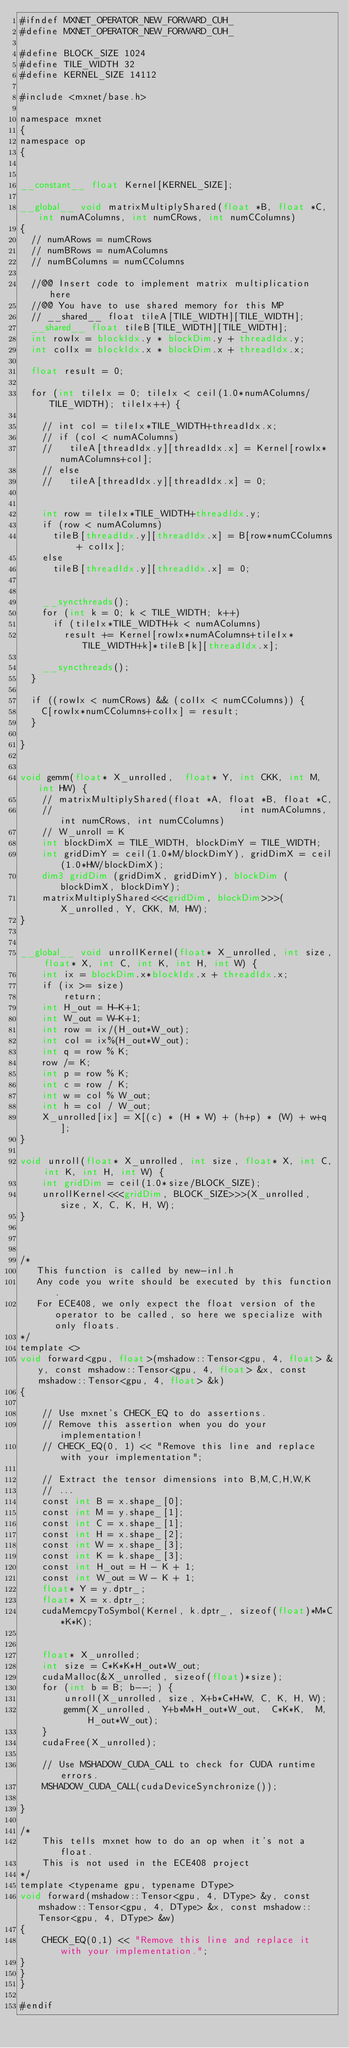Convert code to text. <code><loc_0><loc_0><loc_500><loc_500><_Cuda_>#ifndef MXNET_OPERATOR_NEW_FORWARD_CUH_
#define MXNET_OPERATOR_NEW_FORWARD_CUH_

#define BLOCK_SIZE 1024
#define TILE_WIDTH 32
#define KERNEL_SIZE 14112

#include <mxnet/base.h>

namespace mxnet
{
namespace op
{


__constant__ float Kernel[KERNEL_SIZE];

__global__ void matrixMultiplyShared(float *B, float *C, int numAColumns, int numCRows, int numCColumns) 
{
  // numARows = numCRows
  // numBRows = numAColumns
  // numBColumns = numCColumns

  //@@ Insert code to implement matrix multiplication here
  //@@ You have to use shared memory for this MP
  // __shared__ float tileA[TILE_WIDTH][TILE_WIDTH];
  __shared__ float tileB[TILE_WIDTH][TILE_WIDTH];
  int rowIx = blockIdx.y * blockDim.y + threadIdx.y;
  int colIx = blockIdx.x * blockDim.x + threadIdx.x;

  float result = 0;
  
  for (int tileIx = 0; tileIx < ceil(1.0*numAColumns/TILE_WIDTH); tileIx++) {

    // int col = tileIx*TILE_WIDTH+threadIdx.x;
    // if (col < numAColumns)
    //   tileA[threadIdx.y][threadIdx.x] = Kernel[rowIx*numAColumns+col];
    // else
    //   tileA[threadIdx.y][threadIdx.x] = 0;


    int row = tileIx*TILE_WIDTH+threadIdx.y;
    if (row < numAColumns)
      tileB[threadIdx.y][threadIdx.x] = B[row*numCColumns + colIx];
    else 
      tileB[threadIdx.y][threadIdx.x] = 0;


    __syncthreads();
    for (int k = 0; k < TILE_WIDTH; k++)
      if (tileIx*TILE_WIDTH+k < numAColumns)
        result += Kernel[rowIx*numAColumns+tileIx*TILE_WIDTH+k]*tileB[k][threadIdx.x];
      
    __syncthreads();   
  }
  
  if ((rowIx < numCRows) && (colIx < numCColumns)) {
    C[rowIx*numCColumns+colIx] = result;
  }
  
}


void gemm(float* X_unrolled,  float* Y, int CKK, int M, int HW) {
    // matrixMultiplyShared(float *A, float *B, float *C,
    //                                  int numAColumns, int numCRows, int numCColumns)
    // W_unroll = K
    int blockDimX = TILE_WIDTH, blockDimY = TILE_WIDTH;
    int gridDimY = ceil(1.0*M/blockDimY), gridDimX = ceil(1.0*HW/blockDimX);
    dim3 gridDim (gridDimX, gridDimY), blockDim (blockDimX, blockDimY);
    matrixMultiplyShared<<<gridDim, blockDim>>>(X_unrolled, Y, CKK, M, HW);
}


__global__ void unrollKernel(float* X_unrolled, int size, float* X, int C, int K, int H, int W) {
    int ix = blockDim.x*blockIdx.x + threadIdx.x;
    if (ix >= size)
        return;
    int H_out = H-K+1;
    int W_out = W-K+1;
    int row = ix/(H_out*W_out);
    int col = ix%(H_out*W_out);
    int q = row % K;
    row /= K;
    int p = row % K;
    int c = row / K;
    int w = col % W_out;
    int h = col / W_out;
    X_unrolled[ix] = X[(c) * (H * W) + (h+p) * (W) + w+q];
}

void unroll(float* X_unrolled, int size, float* X, int C, int K, int H, int W) {
    int gridDim = ceil(1.0*size/BLOCK_SIZE);
    unrollKernel<<<gridDim, BLOCK_SIZE>>>(X_unrolled, size, X, C, K, H, W);
}



/* 
   This function is called by new-inl.h
   Any code you write should be executed by this function.
   For ECE408, we only expect the float version of the operator to be called, so here we specialize with only floats.
*/
template <>
void forward<gpu, float>(mshadow::Tensor<gpu, 4, float> &y, const mshadow::Tensor<gpu, 4, float> &x, const mshadow::Tensor<gpu, 4, float> &k)
{

    // Use mxnet's CHECK_EQ to do assertions.
    // Remove this assertion when you do your implementation!
    // CHECK_EQ(0, 1) << "Remove this line and replace with your implementation";

    // Extract the tensor dimensions into B,M,C,H,W,K
    // ...
    const int B = x.shape_[0];
    const int M = y.shape_[1];
    const int C = x.shape_[1];
    const int H = x.shape_[2];
    const int W = x.shape_[3];
    const int K = k.shape_[3];
    const int H_out = H - K + 1;
    const int W_out = W - K + 1;
    float* Y = y.dptr_;
    float* X = x.dptr_;
    cudaMemcpyToSymbol(Kernel, k.dptr_, sizeof(float)*M*C*K*K);


    float* X_unrolled;
    int size = C*K*K*H_out*W_out;
    cudaMalloc(&X_unrolled, sizeof(float)*size);
    for (int b = B; b--; ) {
        unroll(X_unrolled, size, X+b*C*H*W, C, K, H, W);
        gemm(X_unrolled,  Y+b*M*H_out*W_out,  C*K*K,  M,  H_out*W_out);
    }
    cudaFree(X_unrolled);

    // Use MSHADOW_CUDA_CALL to check for CUDA runtime errors.
    MSHADOW_CUDA_CALL(cudaDeviceSynchronize());

}

/* 
    This tells mxnet how to do an op when it's not a float.
    This is not used in the ECE408 project
*/
template <typename gpu, typename DType>
void forward(mshadow::Tensor<gpu, 4, DType> &y, const mshadow::Tensor<gpu, 4, DType> &x, const mshadow::Tensor<gpu, 4, DType> &w)
{
    CHECK_EQ(0,1) << "Remove this line and replace it with your implementation.";
}
}
}

#endif
</code> 